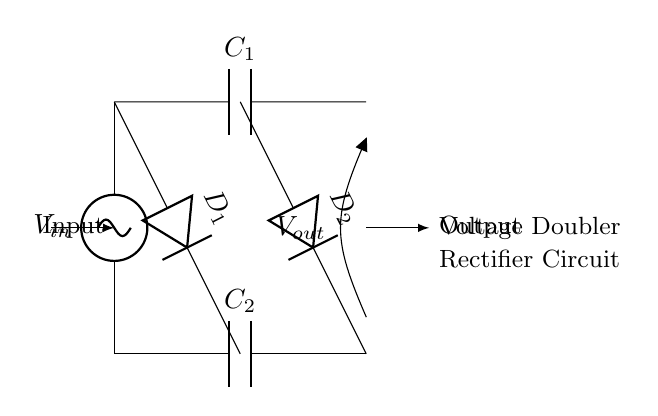What are the two capacitors in the circuit? The circuit contains two capacitors labeled C1 and C2. Capacitor C1 is at the top, and C2 is at the bottom, serving different roles in the voltage doubling process.
Answer: C1, C2 What is the input voltage source labeled as? The input voltage source in the diagram is labeled as V-in, indicating the voltage supplied to the circuit for rectification.
Answer: V-in How many diodes are present in the circuit? The diagram shows two diodes, D1 and D2, which are used to control the direction of current flow in the voltage doubling circuit.
Answer: 2 What is the output voltage labeled as? The output voltage of the circuit is labeled as V-out and represents the boosted voltage obtained after rectification.
Answer: V-out What functionality do the diodes serve in this circuit? Diodes D1 and D2 allow current to flow in only one direction, enabling the conversion of AC input to a higher DC output by blocking reverse currents during the rectification process.
Answer: Rectification How does this circuit achieve voltage doubling? Voltage doubling is accomplished by charging C1 during the positive cycle of the AC input and transferring that charge to C2 during the negative cycle, effectively doubling the voltage seen at V-out.
Answer: Charging and transferring What type of rectifier is represented in this circuit? This circuit represents a voltage doubler rectifier, which specifically boosts the DC output by utilizing capacitors and diodes in an arrangement that leverages AC input voltage.
Answer: Voltage doubler rectifier 